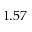<formula> <loc_0><loc_0><loc_500><loc_500>1 . 5 7</formula> 